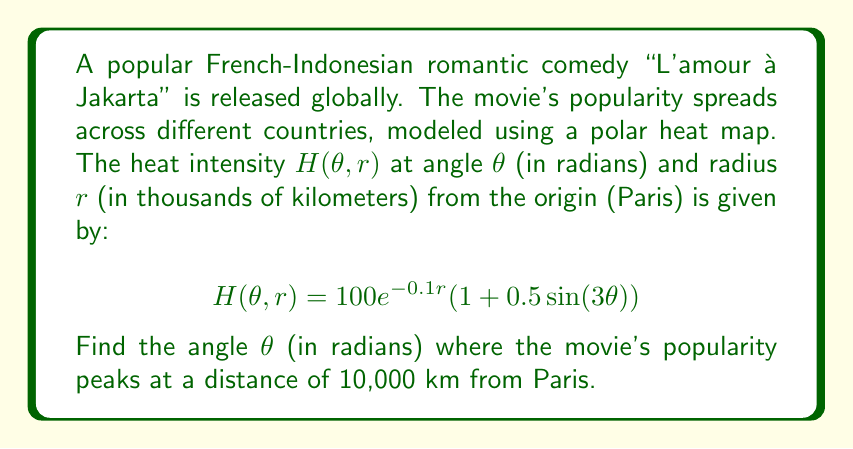Teach me how to tackle this problem. To find the angle where the movie's popularity peaks at a distance of 10,000 km, we need to:

1. Fix $r = 10$ (since $r$ is in thousands of kilometers)
2. Find the maximum of $H(\theta, 10)$ with respect to $\theta$

Let's start:

1. Substitute $r = 10$ into the equation:
   $$H(\theta, 10) = 100e^{-0.1(10)}(1 + 0.5\sin(3\theta))$$
   $$H(\theta, 10) = 100e^{-1}(1 + 0.5\sin(3\theta))$$
   $$H(\theta, 10) = 36.79(1 + 0.5\sin(3\theta))$$

2. To find the maximum, we need to differentiate $H(\theta, 10)$ with respect to $\theta$ and set it to zero:
   $$\frac{d}{d\theta}H(\theta, 10) = 36.79 \cdot 0.5 \cdot 3\cos(3\theta)$$
   $$55.185\cos(3\theta) = 0$$

3. Solve for $\theta$:
   $$\cos(3\theta) = 0$$
   $$3\theta = \frac{\pi}{2} + \pi n, \quad n \in \mathbb{Z}$$
   $$\theta = \frac{\pi}{6} + \frac{\pi n}{3}, \quad n \in \mathbb{Z}$$

4. The solutions in the interval $[0, 2\pi)$ are:
   $$\theta = \frac{\pi}{6}, \frac{\pi}{2}, \frac{5\pi}{6}, \frac{7\pi}{6}, \frac{3\pi}{2}, \frac{11\pi}{6}$$

5. To determine which of these gives the maximum, we can check the second derivative:
   $$\frac{d^2}{d\theta^2}H(\theta, 10) = -36.79 \cdot 0.5 \cdot 9\sin(3\theta)$$

   At $\theta = \frac{\pi}{6}, \frac{5\pi}{6}, \frac{3\pi}{2}$, this is negative, indicating maxima.
   At $\theta = \frac{\pi}{2}, \frac{7\pi}{6}, \frac{11\pi}{6}$, this is positive, indicating minima.

6. Among the maxima, they all give the same peak value. We can choose $\theta = \frac{\pi}{6}$ as our answer.
Answer: $\frac{\pi}{6}$ radians 